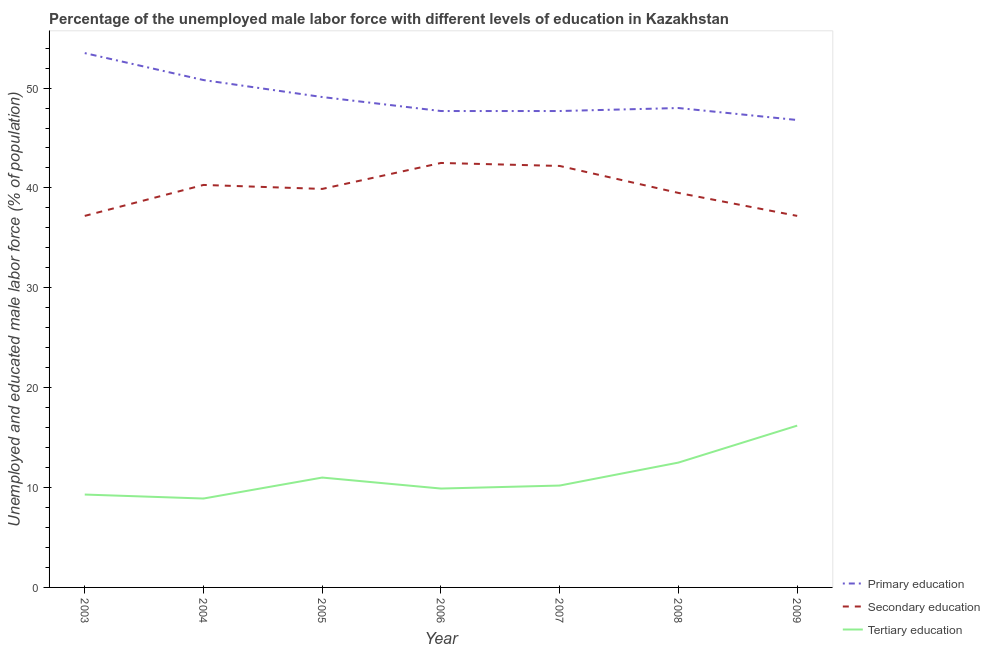How many different coloured lines are there?
Your answer should be compact. 3. Does the line corresponding to percentage of male labor force who received secondary education intersect with the line corresponding to percentage of male labor force who received primary education?
Your response must be concise. No. What is the percentage of male labor force who received tertiary education in 2009?
Offer a terse response. 16.2. Across all years, what is the maximum percentage of male labor force who received secondary education?
Provide a short and direct response. 42.5. Across all years, what is the minimum percentage of male labor force who received tertiary education?
Give a very brief answer. 8.9. In which year was the percentage of male labor force who received secondary education maximum?
Your answer should be very brief. 2006. In which year was the percentage of male labor force who received primary education minimum?
Make the answer very short. 2009. What is the difference between the percentage of male labor force who received primary education in 2007 and that in 2008?
Make the answer very short. -0.3. What is the difference between the percentage of male labor force who received tertiary education in 2008 and the percentage of male labor force who received primary education in 2009?
Offer a very short reply. -34.3. What is the average percentage of male labor force who received tertiary education per year?
Offer a very short reply. 11.14. In the year 2009, what is the difference between the percentage of male labor force who received secondary education and percentage of male labor force who received tertiary education?
Provide a succinct answer. 21. In how many years, is the percentage of male labor force who received secondary education greater than 36 %?
Your answer should be compact. 7. Is the percentage of male labor force who received secondary education in 2005 less than that in 2009?
Offer a very short reply. No. Is the difference between the percentage of male labor force who received primary education in 2003 and 2004 greater than the difference between the percentage of male labor force who received secondary education in 2003 and 2004?
Make the answer very short. Yes. What is the difference between the highest and the second highest percentage of male labor force who received tertiary education?
Your answer should be very brief. 3.7. What is the difference between the highest and the lowest percentage of male labor force who received secondary education?
Keep it short and to the point. 5.3. Is the sum of the percentage of male labor force who received tertiary education in 2004 and 2005 greater than the maximum percentage of male labor force who received primary education across all years?
Ensure brevity in your answer.  No. How many lines are there?
Offer a very short reply. 3. How many years are there in the graph?
Your response must be concise. 7. Are the values on the major ticks of Y-axis written in scientific E-notation?
Offer a terse response. No. Does the graph contain any zero values?
Offer a terse response. No. Does the graph contain grids?
Provide a succinct answer. No. Where does the legend appear in the graph?
Provide a succinct answer. Bottom right. What is the title of the graph?
Provide a short and direct response. Percentage of the unemployed male labor force with different levels of education in Kazakhstan. Does "Spain" appear as one of the legend labels in the graph?
Your answer should be compact. No. What is the label or title of the Y-axis?
Your answer should be very brief. Unemployed and educated male labor force (% of population). What is the Unemployed and educated male labor force (% of population) of Primary education in 2003?
Ensure brevity in your answer.  53.5. What is the Unemployed and educated male labor force (% of population) in Secondary education in 2003?
Your response must be concise. 37.2. What is the Unemployed and educated male labor force (% of population) of Tertiary education in 2003?
Give a very brief answer. 9.3. What is the Unemployed and educated male labor force (% of population) in Primary education in 2004?
Your response must be concise. 50.8. What is the Unemployed and educated male labor force (% of population) in Secondary education in 2004?
Keep it short and to the point. 40.3. What is the Unemployed and educated male labor force (% of population) of Tertiary education in 2004?
Make the answer very short. 8.9. What is the Unemployed and educated male labor force (% of population) of Primary education in 2005?
Ensure brevity in your answer.  49.1. What is the Unemployed and educated male labor force (% of population) of Secondary education in 2005?
Keep it short and to the point. 39.9. What is the Unemployed and educated male labor force (% of population) of Tertiary education in 2005?
Make the answer very short. 11. What is the Unemployed and educated male labor force (% of population) in Primary education in 2006?
Provide a succinct answer. 47.7. What is the Unemployed and educated male labor force (% of population) in Secondary education in 2006?
Make the answer very short. 42.5. What is the Unemployed and educated male labor force (% of population) in Tertiary education in 2006?
Ensure brevity in your answer.  9.9. What is the Unemployed and educated male labor force (% of population) in Primary education in 2007?
Ensure brevity in your answer.  47.7. What is the Unemployed and educated male labor force (% of population) of Secondary education in 2007?
Keep it short and to the point. 42.2. What is the Unemployed and educated male labor force (% of population) in Tertiary education in 2007?
Make the answer very short. 10.2. What is the Unemployed and educated male labor force (% of population) in Secondary education in 2008?
Your answer should be very brief. 39.5. What is the Unemployed and educated male labor force (% of population) of Primary education in 2009?
Your answer should be very brief. 46.8. What is the Unemployed and educated male labor force (% of population) in Secondary education in 2009?
Provide a succinct answer. 37.2. What is the Unemployed and educated male labor force (% of population) in Tertiary education in 2009?
Offer a terse response. 16.2. Across all years, what is the maximum Unemployed and educated male labor force (% of population) in Primary education?
Keep it short and to the point. 53.5. Across all years, what is the maximum Unemployed and educated male labor force (% of population) of Secondary education?
Give a very brief answer. 42.5. Across all years, what is the maximum Unemployed and educated male labor force (% of population) in Tertiary education?
Ensure brevity in your answer.  16.2. Across all years, what is the minimum Unemployed and educated male labor force (% of population) of Primary education?
Your response must be concise. 46.8. Across all years, what is the minimum Unemployed and educated male labor force (% of population) of Secondary education?
Provide a short and direct response. 37.2. Across all years, what is the minimum Unemployed and educated male labor force (% of population) of Tertiary education?
Provide a short and direct response. 8.9. What is the total Unemployed and educated male labor force (% of population) of Primary education in the graph?
Make the answer very short. 343.6. What is the total Unemployed and educated male labor force (% of population) of Secondary education in the graph?
Your answer should be compact. 278.8. What is the total Unemployed and educated male labor force (% of population) in Tertiary education in the graph?
Your response must be concise. 78. What is the difference between the Unemployed and educated male labor force (% of population) of Tertiary education in 2003 and that in 2005?
Your answer should be very brief. -1.7. What is the difference between the Unemployed and educated male labor force (% of population) of Primary education in 2003 and that in 2006?
Your response must be concise. 5.8. What is the difference between the Unemployed and educated male labor force (% of population) in Tertiary education in 2003 and that in 2006?
Give a very brief answer. -0.6. What is the difference between the Unemployed and educated male labor force (% of population) of Primary education in 2003 and that in 2008?
Your answer should be compact. 5.5. What is the difference between the Unemployed and educated male labor force (% of population) in Tertiary education in 2004 and that in 2005?
Give a very brief answer. -2.1. What is the difference between the Unemployed and educated male labor force (% of population) of Primary education in 2004 and that in 2006?
Your answer should be compact. 3.1. What is the difference between the Unemployed and educated male labor force (% of population) of Primary education in 2004 and that in 2007?
Keep it short and to the point. 3.1. What is the difference between the Unemployed and educated male labor force (% of population) of Secondary education in 2004 and that in 2007?
Make the answer very short. -1.9. What is the difference between the Unemployed and educated male labor force (% of population) in Tertiary education in 2004 and that in 2007?
Your response must be concise. -1.3. What is the difference between the Unemployed and educated male labor force (% of population) in Primary education in 2004 and that in 2008?
Your answer should be compact. 2.8. What is the difference between the Unemployed and educated male labor force (% of population) in Tertiary education in 2004 and that in 2008?
Offer a very short reply. -3.6. What is the difference between the Unemployed and educated male labor force (% of population) of Primary education in 2004 and that in 2009?
Offer a terse response. 4. What is the difference between the Unemployed and educated male labor force (% of population) in Secondary education in 2004 and that in 2009?
Your answer should be compact. 3.1. What is the difference between the Unemployed and educated male labor force (% of population) in Tertiary education in 2004 and that in 2009?
Your response must be concise. -7.3. What is the difference between the Unemployed and educated male labor force (% of population) of Primary education in 2005 and that in 2006?
Give a very brief answer. 1.4. What is the difference between the Unemployed and educated male labor force (% of population) in Secondary education in 2005 and that in 2006?
Keep it short and to the point. -2.6. What is the difference between the Unemployed and educated male labor force (% of population) of Tertiary education in 2005 and that in 2006?
Keep it short and to the point. 1.1. What is the difference between the Unemployed and educated male labor force (% of population) in Primary education in 2005 and that in 2007?
Give a very brief answer. 1.4. What is the difference between the Unemployed and educated male labor force (% of population) of Tertiary education in 2005 and that in 2008?
Make the answer very short. -1.5. What is the difference between the Unemployed and educated male labor force (% of population) of Tertiary education in 2005 and that in 2009?
Make the answer very short. -5.2. What is the difference between the Unemployed and educated male labor force (% of population) in Secondary education in 2006 and that in 2007?
Ensure brevity in your answer.  0.3. What is the difference between the Unemployed and educated male labor force (% of population) in Tertiary education in 2006 and that in 2007?
Give a very brief answer. -0.3. What is the difference between the Unemployed and educated male labor force (% of population) of Tertiary education in 2006 and that in 2008?
Make the answer very short. -2.6. What is the difference between the Unemployed and educated male labor force (% of population) of Primary education in 2006 and that in 2009?
Offer a very short reply. 0.9. What is the difference between the Unemployed and educated male labor force (% of population) of Primary education in 2007 and that in 2008?
Provide a succinct answer. -0.3. What is the difference between the Unemployed and educated male labor force (% of population) of Secondary education in 2007 and that in 2008?
Your response must be concise. 2.7. What is the difference between the Unemployed and educated male labor force (% of population) of Primary education in 2007 and that in 2009?
Your answer should be compact. 0.9. What is the difference between the Unemployed and educated male labor force (% of population) of Primary education in 2003 and the Unemployed and educated male labor force (% of population) of Secondary education in 2004?
Ensure brevity in your answer.  13.2. What is the difference between the Unemployed and educated male labor force (% of population) of Primary education in 2003 and the Unemployed and educated male labor force (% of population) of Tertiary education in 2004?
Offer a very short reply. 44.6. What is the difference between the Unemployed and educated male labor force (% of population) in Secondary education in 2003 and the Unemployed and educated male labor force (% of population) in Tertiary education in 2004?
Provide a succinct answer. 28.3. What is the difference between the Unemployed and educated male labor force (% of population) of Primary education in 2003 and the Unemployed and educated male labor force (% of population) of Tertiary education in 2005?
Offer a very short reply. 42.5. What is the difference between the Unemployed and educated male labor force (% of population) of Secondary education in 2003 and the Unemployed and educated male labor force (% of population) of Tertiary education in 2005?
Your answer should be very brief. 26.2. What is the difference between the Unemployed and educated male labor force (% of population) of Primary education in 2003 and the Unemployed and educated male labor force (% of population) of Secondary education in 2006?
Offer a very short reply. 11. What is the difference between the Unemployed and educated male labor force (% of population) of Primary education in 2003 and the Unemployed and educated male labor force (% of population) of Tertiary education in 2006?
Provide a succinct answer. 43.6. What is the difference between the Unemployed and educated male labor force (% of population) of Secondary education in 2003 and the Unemployed and educated male labor force (% of population) of Tertiary education in 2006?
Your answer should be compact. 27.3. What is the difference between the Unemployed and educated male labor force (% of population) in Primary education in 2003 and the Unemployed and educated male labor force (% of population) in Tertiary education in 2007?
Make the answer very short. 43.3. What is the difference between the Unemployed and educated male labor force (% of population) in Primary education in 2003 and the Unemployed and educated male labor force (% of population) in Secondary education in 2008?
Offer a very short reply. 14. What is the difference between the Unemployed and educated male labor force (% of population) of Secondary education in 2003 and the Unemployed and educated male labor force (% of population) of Tertiary education in 2008?
Offer a very short reply. 24.7. What is the difference between the Unemployed and educated male labor force (% of population) of Primary education in 2003 and the Unemployed and educated male labor force (% of population) of Tertiary education in 2009?
Give a very brief answer. 37.3. What is the difference between the Unemployed and educated male labor force (% of population) in Primary education in 2004 and the Unemployed and educated male labor force (% of population) in Tertiary education in 2005?
Give a very brief answer. 39.8. What is the difference between the Unemployed and educated male labor force (% of population) of Secondary education in 2004 and the Unemployed and educated male labor force (% of population) of Tertiary education in 2005?
Your response must be concise. 29.3. What is the difference between the Unemployed and educated male labor force (% of population) of Primary education in 2004 and the Unemployed and educated male labor force (% of population) of Secondary education in 2006?
Offer a very short reply. 8.3. What is the difference between the Unemployed and educated male labor force (% of population) of Primary education in 2004 and the Unemployed and educated male labor force (% of population) of Tertiary education in 2006?
Offer a very short reply. 40.9. What is the difference between the Unemployed and educated male labor force (% of population) in Secondary education in 2004 and the Unemployed and educated male labor force (% of population) in Tertiary education in 2006?
Provide a succinct answer. 30.4. What is the difference between the Unemployed and educated male labor force (% of population) of Primary education in 2004 and the Unemployed and educated male labor force (% of population) of Tertiary education in 2007?
Provide a succinct answer. 40.6. What is the difference between the Unemployed and educated male labor force (% of population) in Secondary education in 2004 and the Unemployed and educated male labor force (% of population) in Tertiary education in 2007?
Make the answer very short. 30.1. What is the difference between the Unemployed and educated male labor force (% of population) in Primary education in 2004 and the Unemployed and educated male labor force (% of population) in Secondary education in 2008?
Provide a succinct answer. 11.3. What is the difference between the Unemployed and educated male labor force (% of population) of Primary education in 2004 and the Unemployed and educated male labor force (% of population) of Tertiary education in 2008?
Offer a very short reply. 38.3. What is the difference between the Unemployed and educated male labor force (% of population) in Secondary education in 2004 and the Unemployed and educated male labor force (% of population) in Tertiary education in 2008?
Provide a succinct answer. 27.8. What is the difference between the Unemployed and educated male labor force (% of population) of Primary education in 2004 and the Unemployed and educated male labor force (% of population) of Tertiary education in 2009?
Give a very brief answer. 34.6. What is the difference between the Unemployed and educated male labor force (% of population) in Secondary education in 2004 and the Unemployed and educated male labor force (% of population) in Tertiary education in 2009?
Offer a very short reply. 24.1. What is the difference between the Unemployed and educated male labor force (% of population) in Primary education in 2005 and the Unemployed and educated male labor force (% of population) in Secondary education in 2006?
Keep it short and to the point. 6.6. What is the difference between the Unemployed and educated male labor force (% of population) in Primary education in 2005 and the Unemployed and educated male labor force (% of population) in Tertiary education in 2006?
Provide a short and direct response. 39.2. What is the difference between the Unemployed and educated male labor force (% of population) in Primary education in 2005 and the Unemployed and educated male labor force (% of population) in Tertiary education in 2007?
Provide a succinct answer. 38.9. What is the difference between the Unemployed and educated male labor force (% of population) in Secondary education in 2005 and the Unemployed and educated male labor force (% of population) in Tertiary education in 2007?
Keep it short and to the point. 29.7. What is the difference between the Unemployed and educated male labor force (% of population) in Primary education in 2005 and the Unemployed and educated male labor force (% of population) in Tertiary education in 2008?
Give a very brief answer. 36.6. What is the difference between the Unemployed and educated male labor force (% of population) in Secondary education in 2005 and the Unemployed and educated male labor force (% of population) in Tertiary education in 2008?
Ensure brevity in your answer.  27.4. What is the difference between the Unemployed and educated male labor force (% of population) of Primary education in 2005 and the Unemployed and educated male labor force (% of population) of Secondary education in 2009?
Offer a very short reply. 11.9. What is the difference between the Unemployed and educated male labor force (% of population) in Primary education in 2005 and the Unemployed and educated male labor force (% of population) in Tertiary education in 2009?
Your answer should be very brief. 32.9. What is the difference between the Unemployed and educated male labor force (% of population) in Secondary education in 2005 and the Unemployed and educated male labor force (% of population) in Tertiary education in 2009?
Ensure brevity in your answer.  23.7. What is the difference between the Unemployed and educated male labor force (% of population) in Primary education in 2006 and the Unemployed and educated male labor force (% of population) in Tertiary education in 2007?
Keep it short and to the point. 37.5. What is the difference between the Unemployed and educated male labor force (% of population) of Secondary education in 2006 and the Unemployed and educated male labor force (% of population) of Tertiary education in 2007?
Your answer should be very brief. 32.3. What is the difference between the Unemployed and educated male labor force (% of population) of Primary education in 2006 and the Unemployed and educated male labor force (% of population) of Tertiary education in 2008?
Your answer should be very brief. 35.2. What is the difference between the Unemployed and educated male labor force (% of population) of Primary education in 2006 and the Unemployed and educated male labor force (% of population) of Tertiary education in 2009?
Ensure brevity in your answer.  31.5. What is the difference between the Unemployed and educated male labor force (% of population) in Secondary education in 2006 and the Unemployed and educated male labor force (% of population) in Tertiary education in 2009?
Ensure brevity in your answer.  26.3. What is the difference between the Unemployed and educated male labor force (% of population) in Primary education in 2007 and the Unemployed and educated male labor force (% of population) in Tertiary education in 2008?
Make the answer very short. 35.2. What is the difference between the Unemployed and educated male labor force (% of population) in Secondary education in 2007 and the Unemployed and educated male labor force (% of population) in Tertiary education in 2008?
Your response must be concise. 29.7. What is the difference between the Unemployed and educated male labor force (% of population) in Primary education in 2007 and the Unemployed and educated male labor force (% of population) in Secondary education in 2009?
Offer a terse response. 10.5. What is the difference between the Unemployed and educated male labor force (% of population) of Primary education in 2007 and the Unemployed and educated male labor force (% of population) of Tertiary education in 2009?
Ensure brevity in your answer.  31.5. What is the difference between the Unemployed and educated male labor force (% of population) in Primary education in 2008 and the Unemployed and educated male labor force (% of population) in Secondary education in 2009?
Provide a short and direct response. 10.8. What is the difference between the Unemployed and educated male labor force (% of population) in Primary education in 2008 and the Unemployed and educated male labor force (% of population) in Tertiary education in 2009?
Make the answer very short. 31.8. What is the difference between the Unemployed and educated male labor force (% of population) in Secondary education in 2008 and the Unemployed and educated male labor force (% of population) in Tertiary education in 2009?
Make the answer very short. 23.3. What is the average Unemployed and educated male labor force (% of population) in Primary education per year?
Your answer should be very brief. 49.09. What is the average Unemployed and educated male labor force (% of population) of Secondary education per year?
Ensure brevity in your answer.  39.83. What is the average Unemployed and educated male labor force (% of population) in Tertiary education per year?
Your answer should be very brief. 11.14. In the year 2003, what is the difference between the Unemployed and educated male labor force (% of population) in Primary education and Unemployed and educated male labor force (% of population) in Tertiary education?
Offer a terse response. 44.2. In the year 2003, what is the difference between the Unemployed and educated male labor force (% of population) in Secondary education and Unemployed and educated male labor force (% of population) in Tertiary education?
Provide a short and direct response. 27.9. In the year 2004, what is the difference between the Unemployed and educated male labor force (% of population) of Primary education and Unemployed and educated male labor force (% of population) of Tertiary education?
Make the answer very short. 41.9. In the year 2004, what is the difference between the Unemployed and educated male labor force (% of population) of Secondary education and Unemployed and educated male labor force (% of population) of Tertiary education?
Ensure brevity in your answer.  31.4. In the year 2005, what is the difference between the Unemployed and educated male labor force (% of population) of Primary education and Unemployed and educated male labor force (% of population) of Tertiary education?
Keep it short and to the point. 38.1. In the year 2005, what is the difference between the Unemployed and educated male labor force (% of population) in Secondary education and Unemployed and educated male labor force (% of population) in Tertiary education?
Give a very brief answer. 28.9. In the year 2006, what is the difference between the Unemployed and educated male labor force (% of population) of Primary education and Unemployed and educated male labor force (% of population) of Tertiary education?
Offer a very short reply. 37.8. In the year 2006, what is the difference between the Unemployed and educated male labor force (% of population) of Secondary education and Unemployed and educated male labor force (% of population) of Tertiary education?
Keep it short and to the point. 32.6. In the year 2007, what is the difference between the Unemployed and educated male labor force (% of population) in Primary education and Unemployed and educated male labor force (% of population) in Secondary education?
Keep it short and to the point. 5.5. In the year 2007, what is the difference between the Unemployed and educated male labor force (% of population) of Primary education and Unemployed and educated male labor force (% of population) of Tertiary education?
Offer a terse response. 37.5. In the year 2008, what is the difference between the Unemployed and educated male labor force (% of population) in Primary education and Unemployed and educated male labor force (% of population) in Tertiary education?
Offer a very short reply. 35.5. In the year 2009, what is the difference between the Unemployed and educated male labor force (% of population) in Primary education and Unemployed and educated male labor force (% of population) in Secondary education?
Your response must be concise. 9.6. In the year 2009, what is the difference between the Unemployed and educated male labor force (% of population) of Primary education and Unemployed and educated male labor force (% of population) of Tertiary education?
Give a very brief answer. 30.6. What is the ratio of the Unemployed and educated male labor force (% of population) of Primary education in 2003 to that in 2004?
Your answer should be compact. 1.05. What is the ratio of the Unemployed and educated male labor force (% of population) in Secondary education in 2003 to that in 2004?
Your response must be concise. 0.92. What is the ratio of the Unemployed and educated male labor force (% of population) of Tertiary education in 2003 to that in 2004?
Offer a terse response. 1.04. What is the ratio of the Unemployed and educated male labor force (% of population) of Primary education in 2003 to that in 2005?
Your answer should be compact. 1.09. What is the ratio of the Unemployed and educated male labor force (% of population) in Secondary education in 2003 to that in 2005?
Provide a succinct answer. 0.93. What is the ratio of the Unemployed and educated male labor force (% of population) in Tertiary education in 2003 to that in 2005?
Make the answer very short. 0.85. What is the ratio of the Unemployed and educated male labor force (% of population) of Primary education in 2003 to that in 2006?
Ensure brevity in your answer.  1.12. What is the ratio of the Unemployed and educated male labor force (% of population) in Secondary education in 2003 to that in 2006?
Your response must be concise. 0.88. What is the ratio of the Unemployed and educated male labor force (% of population) of Tertiary education in 2003 to that in 2006?
Provide a short and direct response. 0.94. What is the ratio of the Unemployed and educated male labor force (% of population) of Primary education in 2003 to that in 2007?
Make the answer very short. 1.12. What is the ratio of the Unemployed and educated male labor force (% of population) of Secondary education in 2003 to that in 2007?
Provide a succinct answer. 0.88. What is the ratio of the Unemployed and educated male labor force (% of population) of Tertiary education in 2003 to that in 2007?
Ensure brevity in your answer.  0.91. What is the ratio of the Unemployed and educated male labor force (% of population) of Primary education in 2003 to that in 2008?
Ensure brevity in your answer.  1.11. What is the ratio of the Unemployed and educated male labor force (% of population) in Secondary education in 2003 to that in 2008?
Keep it short and to the point. 0.94. What is the ratio of the Unemployed and educated male labor force (% of population) in Tertiary education in 2003 to that in 2008?
Make the answer very short. 0.74. What is the ratio of the Unemployed and educated male labor force (% of population) in Primary education in 2003 to that in 2009?
Keep it short and to the point. 1.14. What is the ratio of the Unemployed and educated male labor force (% of population) of Secondary education in 2003 to that in 2009?
Provide a short and direct response. 1. What is the ratio of the Unemployed and educated male labor force (% of population) of Tertiary education in 2003 to that in 2009?
Offer a terse response. 0.57. What is the ratio of the Unemployed and educated male labor force (% of population) in Primary education in 2004 to that in 2005?
Provide a succinct answer. 1.03. What is the ratio of the Unemployed and educated male labor force (% of population) of Secondary education in 2004 to that in 2005?
Ensure brevity in your answer.  1.01. What is the ratio of the Unemployed and educated male labor force (% of population) in Tertiary education in 2004 to that in 2005?
Provide a short and direct response. 0.81. What is the ratio of the Unemployed and educated male labor force (% of population) of Primary education in 2004 to that in 2006?
Provide a short and direct response. 1.06. What is the ratio of the Unemployed and educated male labor force (% of population) of Secondary education in 2004 to that in 2006?
Provide a short and direct response. 0.95. What is the ratio of the Unemployed and educated male labor force (% of population) of Tertiary education in 2004 to that in 2006?
Make the answer very short. 0.9. What is the ratio of the Unemployed and educated male labor force (% of population) in Primary education in 2004 to that in 2007?
Give a very brief answer. 1.06. What is the ratio of the Unemployed and educated male labor force (% of population) in Secondary education in 2004 to that in 2007?
Make the answer very short. 0.95. What is the ratio of the Unemployed and educated male labor force (% of population) of Tertiary education in 2004 to that in 2007?
Ensure brevity in your answer.  0.87. What is the ratio of the Unemployed and educated male labor force (% of population) of Primary education in 2004 to that in 2008?
Give a very brief answer. 1.06. What is the ratio of the Unemployed and educated male labor force (% of population) of Secondary education in 2004 to that in 2008?
Offer a terse response. 1.02. What is the ratio of the Unemployed and educated male labor force (% of population) of Tertiary education in 2004 to that in 2008?
Your answer should be compact. 0.71. What is the ratio of the Unemployed and educated male labor force (% of population) in Primary education in 2004 to that in 2009?
Your answer should be very brief. 1.09. What is the ratio of the Unemployed and educated male labor force (% of population) of Secondary education in 2004 to that in 2009?
Provide a short and direct response. 1.08. What is the ratio of the Unemployed and educated male labor force (% of population) in Tertiary education in 2004 to that in 2009?
Provide a succinct answer. 0.55. What is the ratio of the Unemployed and educated male labor force (% of population) in Primary education in 2005 to that in 2006?
Provide a succinct answer. 1.03. What is the ratio of the Unemployed and educated male labor force (% of population) of Secondary education in 2005 to that in 2006?
Offer a very short reply. 0.94. What is the ratio of the Unemployed and educated male labor force (% of population) in Tertiary education in 2005 to that in 2006?
Your answer should be compact. 1.11. What is the ratio of the Unemployed and educated male labor force (% of population) in Primary education in 2005 to that in 2007?
Provide a succinct answer. 1.03. What is the ratio of the Unemployed and educated male labor force (% of population) of Secondary education in 2005 to that in 2007?
Give a very brief answer. 0.95. What is the ratio of the Unemployed and educated male labor force (% of population) in Tertiary education in 2005 to that in 2007?
Your response must be concise. 1.08. What is the ratio of the Unemployed and educated male labor force (% of population) in Primary education in 2005 to that in 2008?
Your answer should be compact. 1.02. What is the ratio of the Unemployed and educated male labor force (% of population) of Tertiary education in 2005 to that in 2008?
Provide a short and direct response. 0.88. What is the ratio of the Unemployed and educated male labor force (% of population) of Primary education in 2005 to that in 2009?
Provide a short and direct response. 1.05. What is the ratio of the Unemployed and educated male labor force (% of population) of Secondary education in 2005 to that in 2009?
Offer a very short reply. 1.07. What is the ratio of the Unemployed and educated male labor force (% of population) in Tertiary education in 2005 to that in 2009?
Your answer should be compact. 0.68. What is the ratio of the Unemployed and educated male labor force (% of population) in Primary education in 2006 to that in 2007?
Make the answer very short. 1. What is the ratio of the Unemployed and educated male labor force (% of population) of Secondary education in 2006 to that in 2007?
Offer a very short reply. 1.01. What is the ratio of the Unemployed and educated male labor force (% of population) in Tertiary education in 2006 to that in 2007?
Keep it short and to the point. 0.97. What is the ratio of the Unemployed and educated male labor force (% of population) of Secondary education in 2006 to that in 2008?
Provide a short and direct response. 1.08. What is the ratio of the Unemployed and educated male labor force (% of population) in Tertiary education in 2006 to that in 2008?
Offer a very short reply. 0.79. What is the ratio of the Unemployed and educated male labor force (% of population) of Primary education in 2006 to that in 2009?
Offer a very short reply. 1.02. What is the ratio of the Unemployed and educated male labor force (% of population) in Secondary education in 2006 to that in 2009?
Keep it short and to the point. 1.14. What is the ratio of the Unemployed and educated male labor force (% of population) in Tertiary education in 2006 to that in 2009?
Offer a very short reply. 0.61. What is the ratio of the Unemployed and educated male labor force (% of population) in Primary education in 2007 to that in 2008?
Your answer should be very brief. 0.99. What is the ratio of the Unemployed and educated male labor force (% of population) in Secondary education in 2007 to that in 2008?
Offer a terse response. 1.07. What is the ratio of the Unemployed and educated male labor force (% of population) in Tertiary education in 2007 to that in 2008?
Give a very brief answer. 0.82. What is the ratio of the Unemployed and educated male labor force (% of population) in Primary education in 2007 to that in 2009?
Offer a very short reply. 1.02. What is the ratio of the Unemployed and educated male labor force (% of population) of Secondary education in 2007 to that in 2009?
Offer a terse response. 1.13. What is the ratio of the Unemployed and educated male labor force (% of population) of Tertiary education in 2007 to that in 2009?
Provide a short and direct response. 0.63. What is the ratio of the Unemployed and educated male labor force (% of population) of Primary education in 2008 to that in 2009?
Offer a very short reply. 1.03. What is the ratio of the Unemployed and educated male labor force (% of population) of Secondary education in 2008 to that in 2009?
Offer a terse response. 1.06. What is the ratio of the Unemployed and educated male labor force (% of population) in Tertiary education in 2008 to that in 2009?
Your answer should be compact. 0.77. 